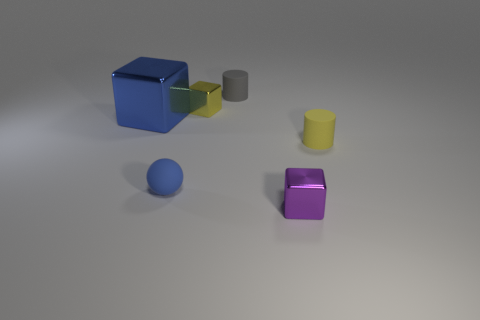Add 3 blocks. How many objects exist? 9 Subtract all cylinders. How many objects are left? 4 Add 1 brown metal spheres. How many brown metal spheres exist? 1 Subtract 0 cyan cubes. How many objects are left? 6 Subtract all yellow metallic things. Subtract all big blue things. How many objects are left? 4 Add 3 tiny yellow rubber objects. How many tiny yellow rubber objects are left? 4 